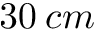Convert formula to latex. <formula><loc_0><loc_0><loc_500><loc_500>3 0 \, c m</formula> 